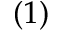Convert formula to latex. <formula><loc_0><loc_0><loc_500><loc_500>( 1 )</formula> 